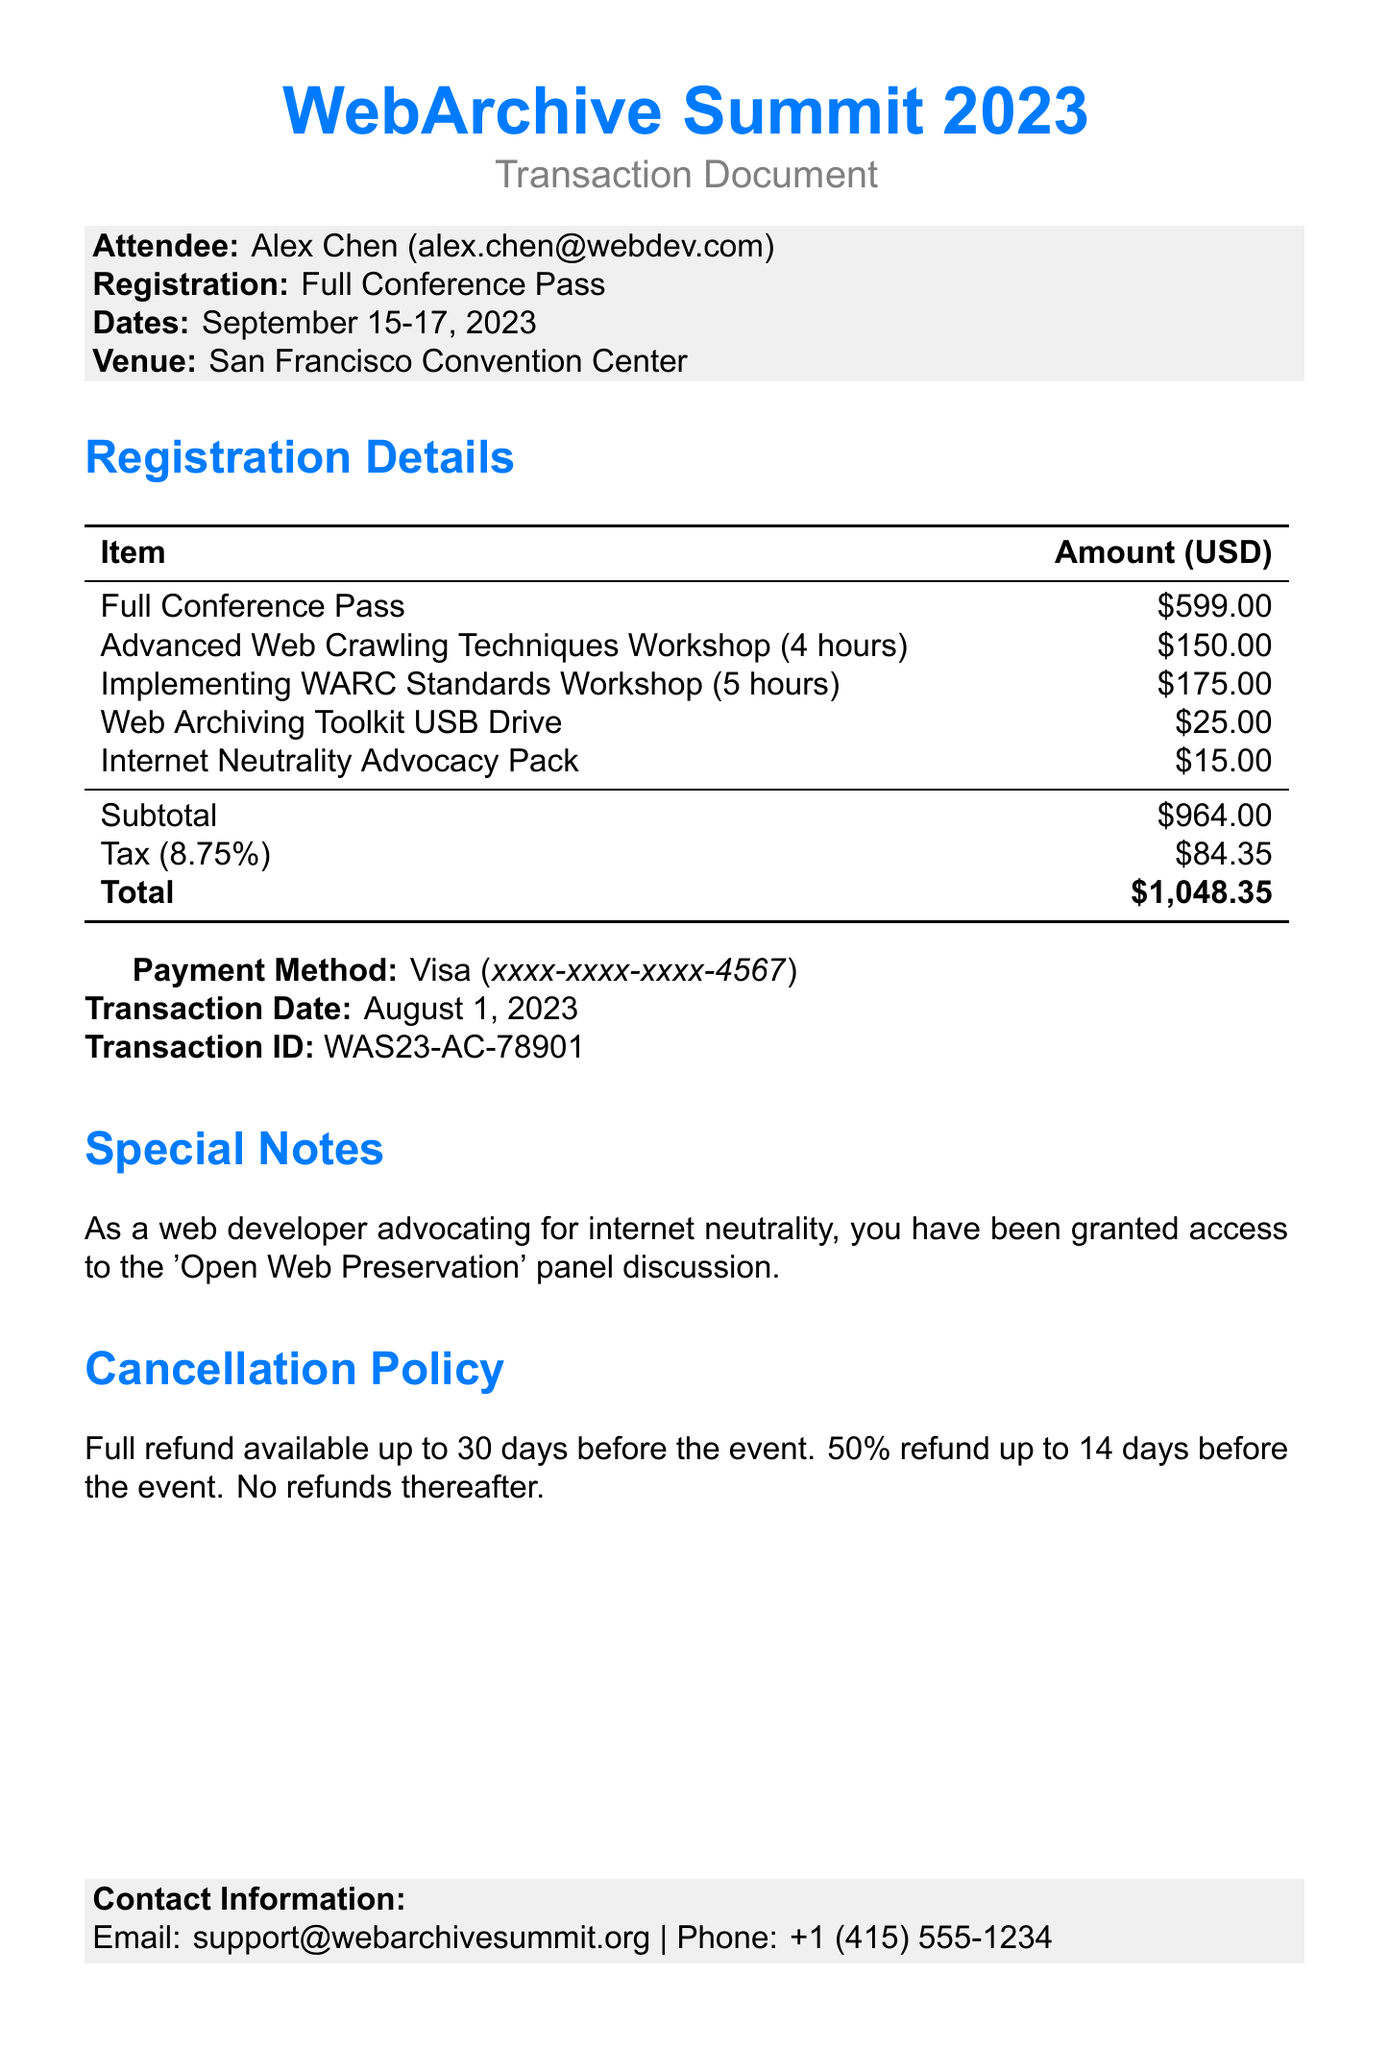What is the name of the conference? The conference name is explicitly mentioned in the document.
Answer: WebArchive Summit 2023 Who is the organizer of the conference? The organizer is stated in the document.
Answer: Internet Archive Foundation What is the total amount paid? The total amount is clearly presented in the document.
Answer: $1,048.35 What is the fee for the workshop on Advanced Web Crawling Techniques? The fee for this specific workshop is stated in the registration details.
Answer: $150.00 What is the transaction date? The date of the transaction can be found in the document.
Answer: August 1, 2023 How many hours is the "Implementing WARC Standards in Archiving Tools" workshop? The duration of this workshop is mentioned in the document.
Answer: 5 hours What is the cancellation policy for refunds? The document outlines the rules for refunds, indicating different terms based on timeframes.
Answer: Full refund available up to 30 days before the event. 50% refund up to 14 days before the event. No refunds thereafter What special access has been granted due to the attendee's advocacy? The document notes specific access based on the attendee's background.
Answer: Access to the 'Open Web Preservation' panel discussion 